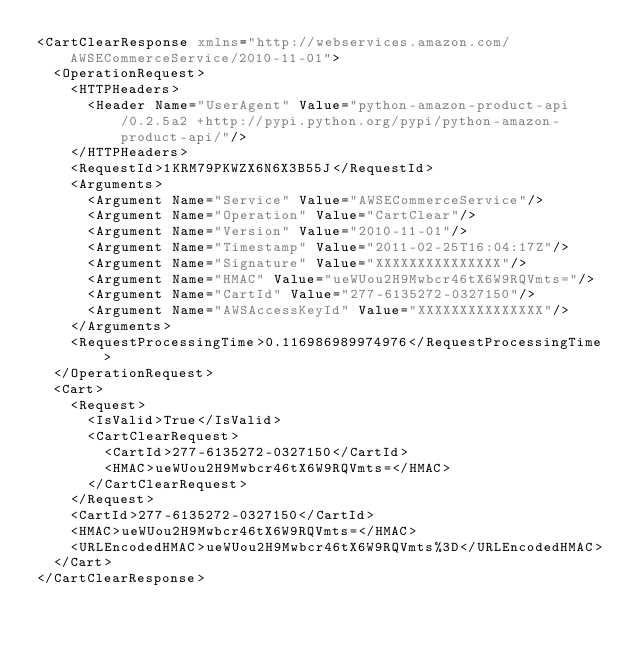Convert code to text. <code><loc_0><loc_0><loc_500><loc_500><_XML_><CartClearResponse xmlns="http://webservices.amazon.com/AWSECommerceService/2010-11-01">
  <OperationRequest>
    <HTTPHeaders>
      <Header Name="UserAgent" Value="python-amazon-product-api/0.2.5a2 +http://pypi.python.org/pypi/python-amazon-product-api/"/>
    </HTTPHeaders>
    <RequestId>1KRM79PKWZX6N6X3B55J</RequestId>
    <Arguments>
      <Argument Name="Service" Value="AWSECommerceService"/>
      <Argument Name="Operation" Value="CartClear"/>
      <Argument Name="Version" Value="2010-11-01"/>
      <Argument Name="Timestamp" Value="2011-02-25T16:04:17Z"/>
      <Argument Name="Signature" Value="XXXXXXXXXXXXXXX"/>
      <Argument Name="HMAC" Value="ueWUou2H9Mwbcr46tX6W9RQVmts="/>
      <Argument Name="CartId" Value="277-6135272-0327150"/>
      <Argument Name="AWSAccessKeyId" Value="XXXXXXXXXXXXXXX"/>
    </Arguments>
    <RequestProcessingTime>0.116986989974976</RequestProcessingTime>
  </OperationRequest>
  <Cart>
    <Request>
      <IsValid>True</IsValid>
      <CartClearRequest>
        <CartId>277-6135272-0327150</CartId>
        <HMAC>ueWUou2H9Mwbcr46tX6W9RQVmts=</HMAC>
      </CartClearRequest>
    </Request>
    <CartId>277-6135272-0327150</CartId>
    <HMAC>ueWUou2H9Mwbcr46tX6W9RQVmts=</HMAC>
    <URLEncodedHMAC>ueWUou2H9Mwbcr46tX6W9RQVmts%3D</URLEncodedHMAC>
  </Cart>
</CartClearResponse>
</code> 